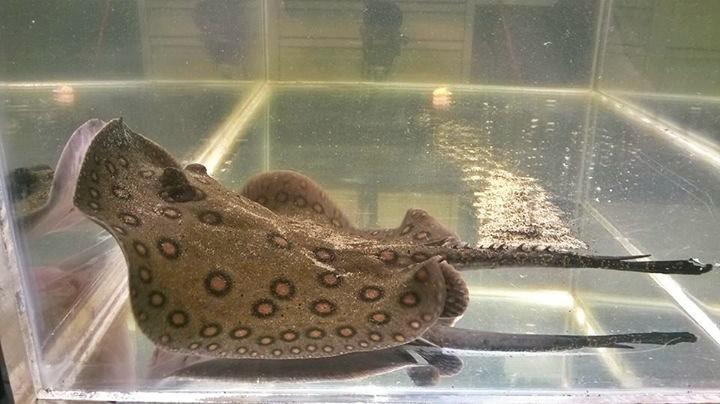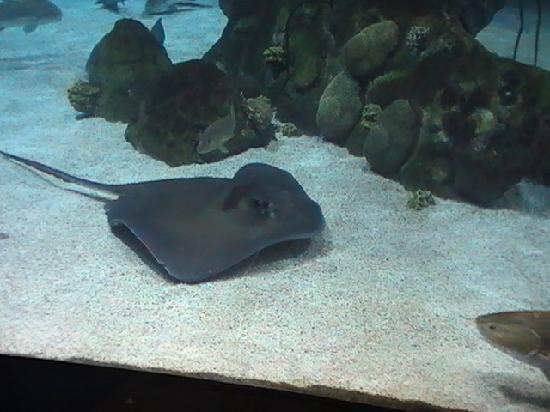The first image is the image on the left, the second image is the image on the right. For the images displayed, is the sentence "In the left image, a fish is visible in the tank with a sting ray." factually correct? Answer yes or no. No. The first image is the image on the left, the second image is the image on the right. For the images shown, is this caption "The left and right image contains a total two stingrays and one fish." true? Answer yes or no. Yes. 